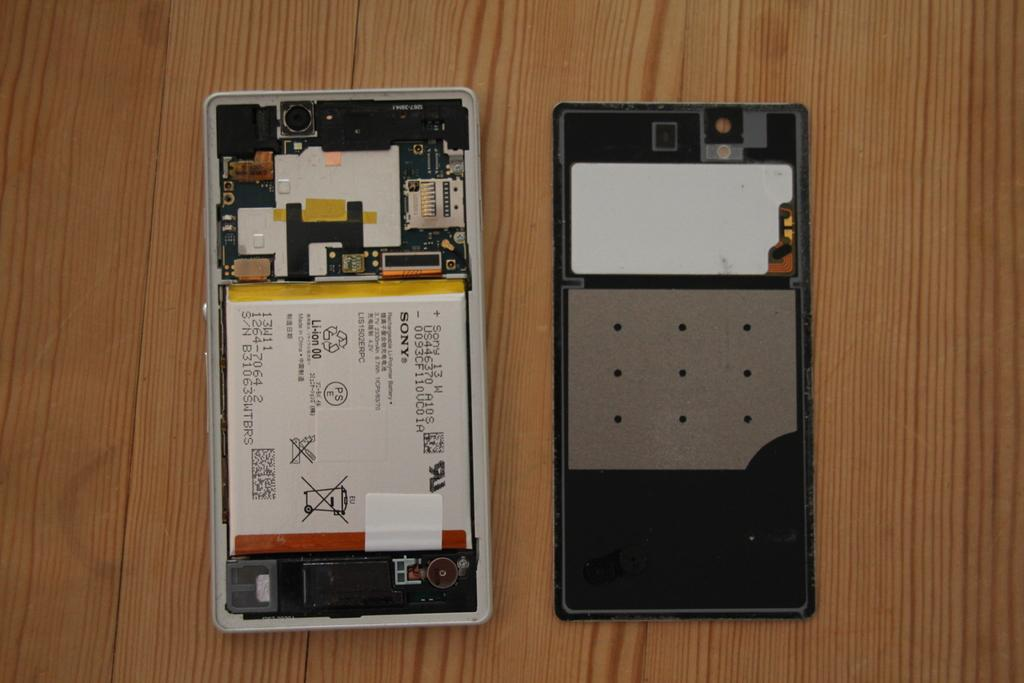<image>
Provide a brief description of the given image. A cell phone is open to reveal a battery with the name Sony on it. 